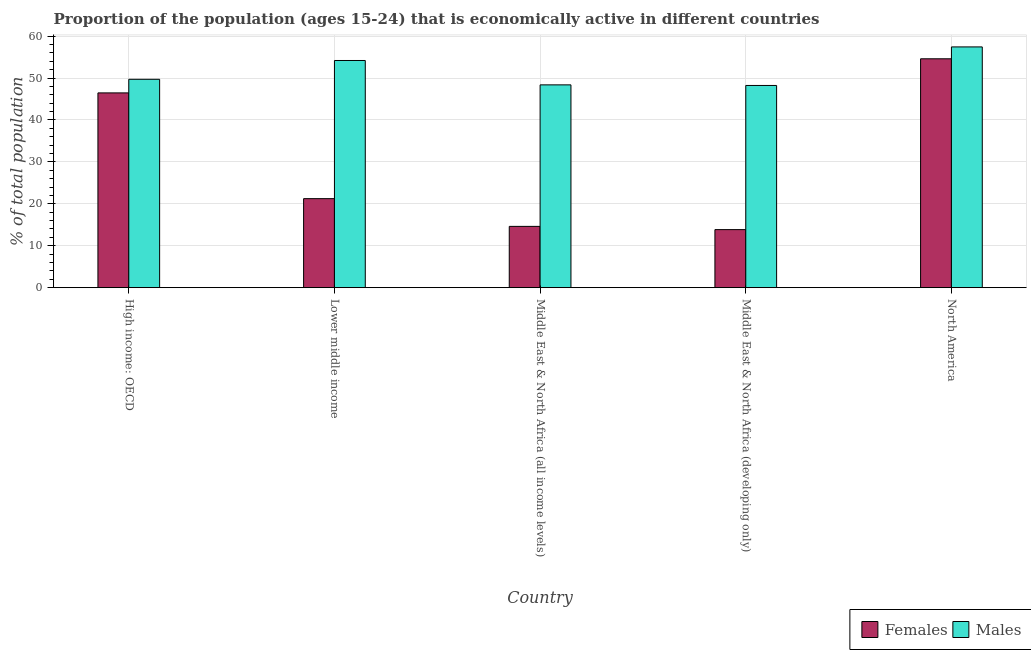How many different coloured bars are there?
Offer a terse response. 2. How many bars are there on the 4th tick from the left?
Your response must be concise. 2. What is the label of the 3rd group of bars from the left?
Ensure brevity in your answer.  Middle East & North Africa (all income levels). What is the percentage of economically active male population in Middle East & North Africa (developing only)?
Ensure brevity in your answer.  48.22. Across all countries, what is the maximum percentage of economically active male population?
Ensure brevity in your answer.  57.41. Across all countries, what is the minimum percentage of economically active female population?
Offer a very short reply. 13.84. In which country was the percentage of economically active male population maximum?
Make the answer very short. North America. In which country was the percentage of economically active female population minimum?
Your response must be concise. Middle East & North Africa (developing only). What is the total percentage of economically active female population in the graph?
Your answer should be very brief. 150.71. What is the difference between the percentage of economically active male population in High income: OECD and that in Middle East & North Africa (developing only)?
Your response must be concise. 1.47. What is the difference between the percentage of economically active female population in Lower middle income and the percentage of economically active male population in High income: OECD?
Your response must be concise. -28.46. What is the average percentage of economically active male population per country?
Ensure brevity in your answer.  51.57. What is the difference between the percentage of economically active male population and percentage of economically active female population in High income: OECD?
Provide a succinct answer. 3.24. In how many countries, is the percentage of economically active male population greater than 26 %?
Offer a terse response. 5. What is the ratio of the percentage of economically active female population in Middle East & North Africa (all income levels) to that in Middle East & North Africa (developing only)?
Provide a succinct answer. 1.06. What is the difference between the highest and the second highest percentage of economically active female population?
Give a very brief answer. 8.13. What is the difference between the highest and the lowest percentage of economically active male population?
Your response must be concise. 9.19. In how many countries, is the percentage of economically active female population greater than the average percentage of economically active female population taken over all countries?
Ensure brevity in your answer.  2. What does the 2nd bar from the left in Middle East & North Africa (all income levels) represents?
Offer a terse response. Males. What does the 1st bar from the right in Middle East & North Africa (all income levels) represents?
Offer a terse response. Males. How many bars are there?
Your answer should be very brief. 10. What is the difference between two consecutive major ticks on the Y-axis?
Provide a short and direct response. 10. Does the graph contain any zero values?
Your answer should be compact. No. Does the graph contain grids?
Your answer should be very brief. Yes. How many legend labels are there?
Ensure brevity in your answer.  2. What is the title of the graph?
Offer a terse response. Proportion of the population (ages 15-24) that is economically active in different countries. What is the label or title of the Y-axis?
Ensure brevity in your answer.  % of total population. What is the % of total population in Females in High income: OECD?
Give a very brief answer. 46.45. What is the % of total population in Males in High income: OECD?
Offer a very short reply. 49.69. What is the % of total population of Females in Lower middle income?
Your response must be concise. 21.23. What is the % of total population of Males in Lower middle income?
Give a very brief answer. 54.17. What is the % of total population of Females in Middle East & North Africa (all income levels)?
Offer a very short reply. 14.61. What is the % of total population of Males in Middle East & North Africa (all income levels)?
Your answer should be very brief. 48.36. What is the % of total population of Females in Middle East & North Africa (developing only)?
Offer a very short reply. 13.84. What is the % of total population in Males in Middle East & North Africa (developing only)?
Your answer should be compact. 48.22. What is the % of total population of Females in North America?
Keep it short and to the point. 54.58. What is the % of total population in Males in North America?
Ensure brevity in your answer.  57.41. Across all countries, what is the maximum % of total population in Females?
Offer a very short reply. 54.58. Across all countries, what is the maximum % of total population in Males?
Your response must be concise. 57.41. Across all countries, what is the minimum % of total population of Females?
Ensure brevity in your answer.  13.84. Across all countries, what is the minimum % of total population in Males?
Offer a terse response. 48.22. What is the total % of total population in Females in the graph?
Make the answer very short. 150.71. What is the total % of total population of Males in the graph?
Make the answer very short. 257.86. What is the difference between the % of total population in Females in High income: OECD and that in Lower middle income?
Your response must be concise. 25.22. What is the difference between the % of total population in Males in High income: OECD and that in Lower middle income?
Your answer should be very brief. -4.48. What is the difference between the % of total population in Females in High income: OECD and that in Middle East & North Africa (all income levels)?
Provide a short and direct response. 31.84. What is the difference between the % of total population of Males in High income: OECD and that in Middle East & North Africa (all income levels)?
Your answer should be very brief. 1.33. What is the difference between the % of total population in Females in High income: OECD and that in Middle East & North Africa (developing only)?
Provide a short and direct response. 32.61. What is the difference between the % of total population of Males in High income: OECD and that in Middle East & North Africa (developing only)?
Make the answer very short. 1.47. What is the difference between the % of total population in Females in High income: OECD and that in North America?
Ensure brevity in your answer.  -8.13. What is the difference between the % of total population in Males in High income: OECD and that in North America?
Provide a short and direct response. -7.72. What is the difference between the % of total population of Females in Lower middle income and that in Middle East & North Africa (all income levels)?
Ensure brevity in your answer.  6.61. What is the difference between the % of total population of Males in Lower middle income and that in Middle East & North Africa (all income levels)?
Your answer should be compact. 5.81. What is the difference between the % of total population in Females in Lower middle income and that in Middle East & North Africa (developing only)?
Your answer should be very brief. 7.38. What is the difference between the % of total population of Males in Lower middle income and that in Middle East & North Africa (developing only)?
Make the answer very short. 5.95. What is the difference between the % of total population of Females in Lower middle income and that in North America?
Offer a very short reply. -33.35. What is the difference between the % of total population of Males in Lower middle income and that in North America?
Provide a succinct answer. -3.24. What is the difference between the % of total population in Females in Middle East & North Africa (all income levels) and that in Middle East & North Africa (developing only)?
Your answer should be very brief. 0.77. What is the difference between the % of total population in Males in Middle East & North Africa (all income levels) and that in Middle East & North Africa (developing only)?
Keep it short and to the point. 0.14. What is the difference between the % of total population in Females in Middle East & North Africa (all income levels) and that in North America?
Offer a very short reply. -39.97. What is the difference between the % of total population of Males in Middle East & North Africa (all income levels) and that in North America?
Your answer should be very brief. -9.05. What is the difference between the % of total population of Females in Middle East & North Africa (developing only) and that in North America?
Offer a terse response. -40.74. What is the difference between the % of total population in Males in Middle East & North Africa (developing only) and that in North America?
Provide a short and direct response. -9.19. What is the difference between the % of total population of Females in High income: OECD and the % of total population of Males in Lower middle income?
Your answer should be compact. -7.73. What is the difference between the % of total population of Females in High income: OECD and the % of total population of Males in Middle East & North Africa (all income levels)?
Give a very brief answer. -1.92. What is the difference between the % of total population of Females in High income: OECD and the % of total population of Males in Middle East & North Africa (developing only)?
Give a very brief answer. -1.77. What is the difference between the % of total population of Females in High income: OECD and the % of total population of Males in North America?
Your answer should be very brief. -10.97. What is the difference between the % of total population in Females in Lower middle income and the % of total population in Males in Middle East & North Africa (all income levels)?
Provide a short and direct response. -27.14. What is the difference between the % of total population of Females in Lower middle income and the % of total population of Males in Middle East & North Africa (developing only)?
Make the answer very short. -26.99. What is the difference between the % of total population of Females in Lower middle income and the % of total population of Males in North America?
Give a very brief answer. -36.19. What is the difference between the % of total population of Females in Middle East & North Africa (all income levels) and the % of total population of Males in Middle East & North Africa (developing only)?
Ensure brevity in your answer.  -33.61. What is the difference between the % of total population in Females in Middle East & North Africa (all income levels) and the % of total population in Males in North America?
Offer a terse response. -42.8. What is the difference between the % of total population of Females in Middle East & North Africa (developing only) and the % of total population of Males in North America?
Keep it short and to the point. -43.57. What is the average % of total population of Females per country?
Make the answer very short. 30.14. What is the average % of total population in Males per country?
Provide a short and direct response. 51.57. What is the difference between the % of total population in Females and % of total population in Males in High income: OECD?
Provide a succinct answer. -3.24. What is the difference between the % of total population in Females and % of total population in Males in Lower middle income?
Provide a succinct answer. -32.95. What is the difference between the % of total population of Females and % of total population of Males in Middle East & North Africa (all income levels)?
Provide a succinct answer. -33.75. What is the difference between the % of total population in Females and % of total population in Males in Middle East & North Africa (developing only)?
Provide a short and direct response. -34.38. What is the difference between the % of total population of Females and % of total population of Males in North America?
Your answer should be very brief. -2.83. What is the ratio of the % of total population of Females in High income: OECD to that in Lower middle income?
Ensure brevity in your answer.  2.19. What is the ratio of the % of total population of Males in High income: OECD to that in Lower middle income?
Offer a terse response. 0.92. What is the ratio of the % of total population of Females in High income: OECD to that in Middle East & North Africa (all income levels)?
Your answer should be compact. 3.18. What is the ratio of the % of total population of Males in High income: OECD to that in Middle East & North Africa (all income levels)?
Offer a very short reply. 1.03. What is the ratio of the % of total population in Females in High income: OECD to that in Middle East & North Africa (developing only)?
Your response must be concise. 3.36. What is the ratio of the % of total population in Males in High income: OECD to that in Middle East & North Africa (developing only)?
Your answer should be very brief. 1.03. What is the ratio of the % of total population of Females in High income: OECD to that in North America?
Provide a short and direct response. 0.85. What is the ratio of the % of total population in Males in High income: OECD to that in North America?
Provide a short and direct response. 0.87. What is the ratio of the % of total population in Females in Lower middle income to that in Middle East & North Africa (all income levels)?
Ensure brevity in your answer.  1.45. What is the ratio of the % of total population in Males in Lower middle income to that in Middle East & North Africa (all income levels)?
Your answer should be very brief. 1.12. What is the ratio of the % of total population in Females in Lower middle income to that in Middle East & North Africa (developing only)?
Keep it short and to the point. 1.53. What is the ratio of the % of total population of Males in Lower middle income to that in Middle East & North Africa (developing only)?
Offer a terse response. 1.12. What is the ratio of the % of total population of Females in Lower middle income to that in North America?
Your response must be concise. 0.39. What is the ratio of the % of total population in Males in Lower middle income to that in North America?
Provide a short and direct response. 0.94. What is the ratio of the % of total population of Females in Middle East & North Africa (all income levels) to that in Middle East & North Africa (developing only)?
Make the answer very short. 1.06. What is the ratio of the % of total population in Females in Middle East & North Africa (all income levels) to that in North America?
Ensure brevity in your answer.  0.27. What is the ratio of the % of total population in Males in Middle East & North Africa (all income levels) to that in North America?
Keep it short and to the point. 0.84. What is the ratio of the % of total population in Females in Middle East & North Africa (developing only) to that in North America?
Make the answer very short. 0.25. What is the ratio of the % of total population of Males in Middle East & North Africa (developing only) to that in North America?
Make the answer very short. 0.84. What is the difference between the highest and the second highest % of total population of Females?
Your response must be concise. 8.13. What is the difference between the highest and the second highest % of total population of Males?
Give a very brief answer. 3.24. What is the difference between the highest and the lowest % of total population of Females?
Offer a very short reply. 40.74. What is the difference between the highest and the lowest % of total population in Males?
Offer a terse response. 9.19. 